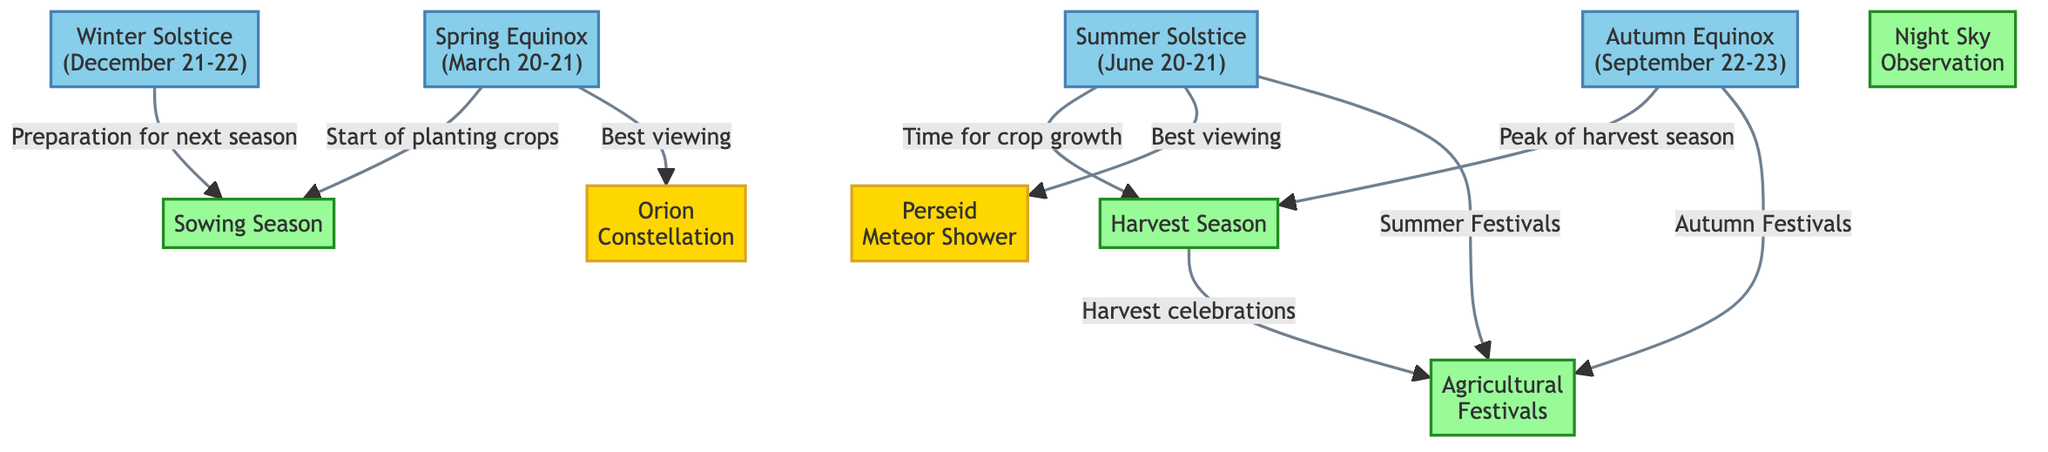What is the first event listed under Spring Equinox? The diagram indicates that the Spring Equinox is associated with the start of the planting crops, which is the first activity linked to it.
Answer: Start of planting crops Which activity is associated with the Summer Solstice? The Summer Solstice is linked to three activities: the time for crop growth, best viewing of the Perseid Meteor Shower, and summer festivals. The first activities mentioned are prominent in the relations.
Answer: Time for crop growth How many seasonal events are listed in the diagram? The diagram shows four seasonal events: Spring Equinox, Summer Solstice, Autumn Equinox, and Winter Solstice. To find the total, I count each one shown in the diagram.
Answer: 4 What constellation is best viewed during the Spring Equinox? The Spring Equinox is linked to the best viewing of the Orion constellation. Analyzing the diagram, Orion is specifically noted under that season's connections.
Answer: Orion constellation During which season is the peak of the harvest season? According to the diagram, the peak of harvest season is related to the Autumn Equinox. This connection is directly drawn from the seasonal flow of the diagram.
Answer: Autumn Equinox Which celestial event is best viewed in summer? The diagram specifies that the best viewing for the Perseid Meteor Shower occurs during the Summer Solstice. By identifying the activities linked to that season, this particular celestial event stands out.
Answer: Perseid Meteor Shower What activity follows the preparation for the next season? The preparation for the next season, associated with the Winter Solstice, links back to the sowing season. This means that following preparation, the farming cycle continues.
Answer: Sowing Season How are harvest season and agricultural festivals related? Harvest season is linked to harvest celebrations, which directly ties in with agricultural festivals. By reviewing the connections in the diagram, they show a sequence of related events in the farming calendar.
Answer: Harvest celebrations Which season is associated with Autumn Festivals? According to the diagram, the Autumn Equinox directly links to Autumn Festivals. This is evident in how the seasonal information integrates with festival activities.
Answer: Autumn Equinox 